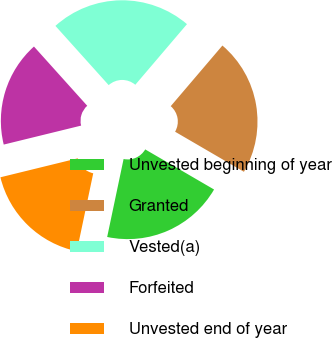Convert chart. <chart><loc_0><loc_0><loc_500><loc_500><pie_chart><fcel>Unvested beginning of year<fcel>Granted<fcel>Vested(a)<fcel>Forfeited<fcel>Unvested end of year<nl><fcel>19.91%<fcel>22.16%<fcel>22.89%<fcel>17.17%<fcel>17.87%<nl></chart> 